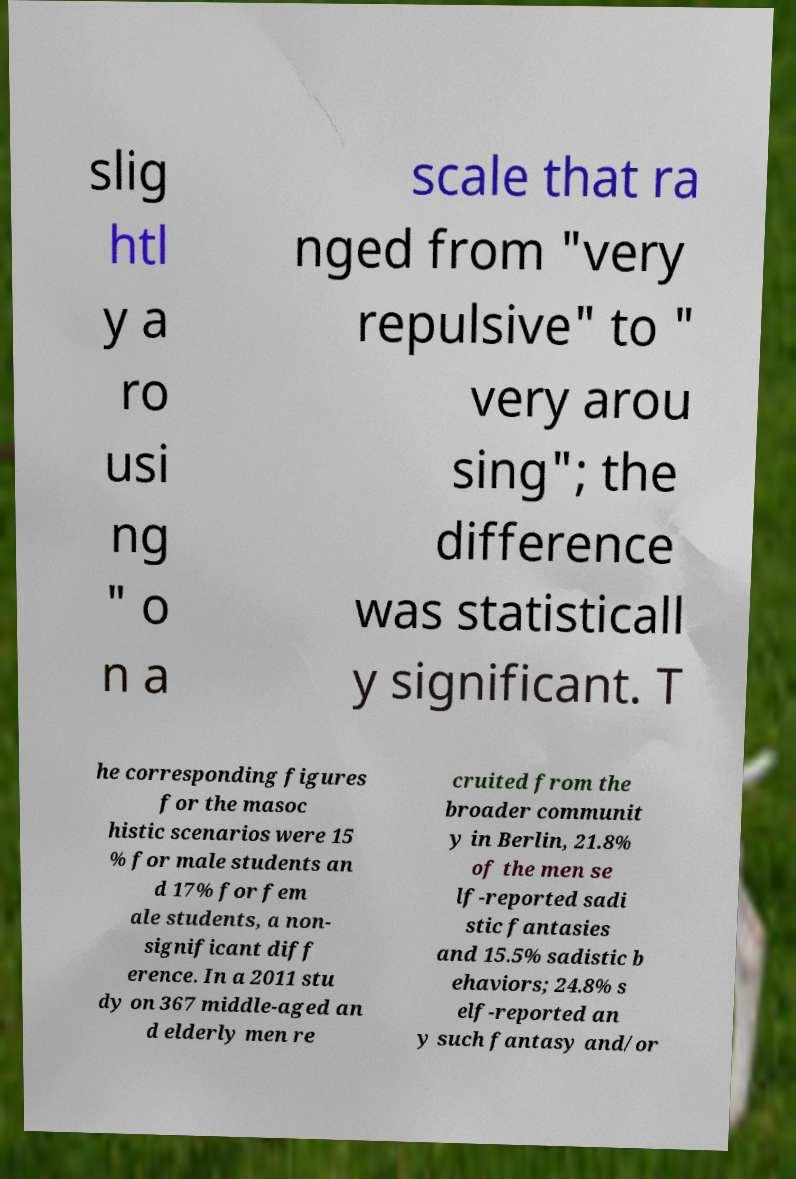Can you accurately transcribe the text from the provided image for me? slig htl y a ro usi ng " o n a scale that ra nged from "very repulsive" to " very arou sing"; the difference was statisticall y significant. T he corresponding figures for the masoc histic scenarios were 15 % for male students an d 17% for fem ale students, a non- significant diff erence. In a 2011 stu dy on 367 middle-aged an d elderly men re cruited from the broader communit y in Berlin, 21.8% of the men se lf-reported sadi stic fantasies and 15.5% sadistic b ehaviors; 24.8% s elf-reported an y such fantasy and/or 